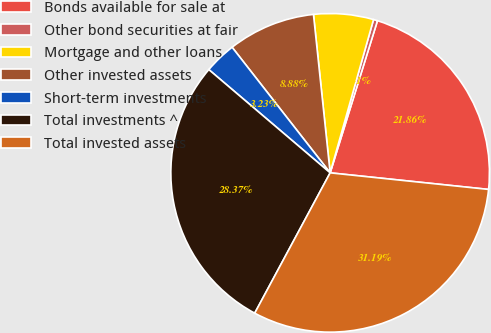Convert chart. <chart><loc_0><loc_0><loc_500><loc_500><pie_chart><fcel>Bonds available for sale at<fcel>Other bond securities at fair<fcel>Mortgage and other loans<fcel>Other invested assets<fcel>Short-term investments<fcel>Total investments ^<fcel>Total invested assets<nl><fcel>21.86%<fcel>0.41%<fcel>6.06%<fcel>8.88%<fcel>3.23%<fcel>28.37%<fcel>31.19%<nl></chart> 